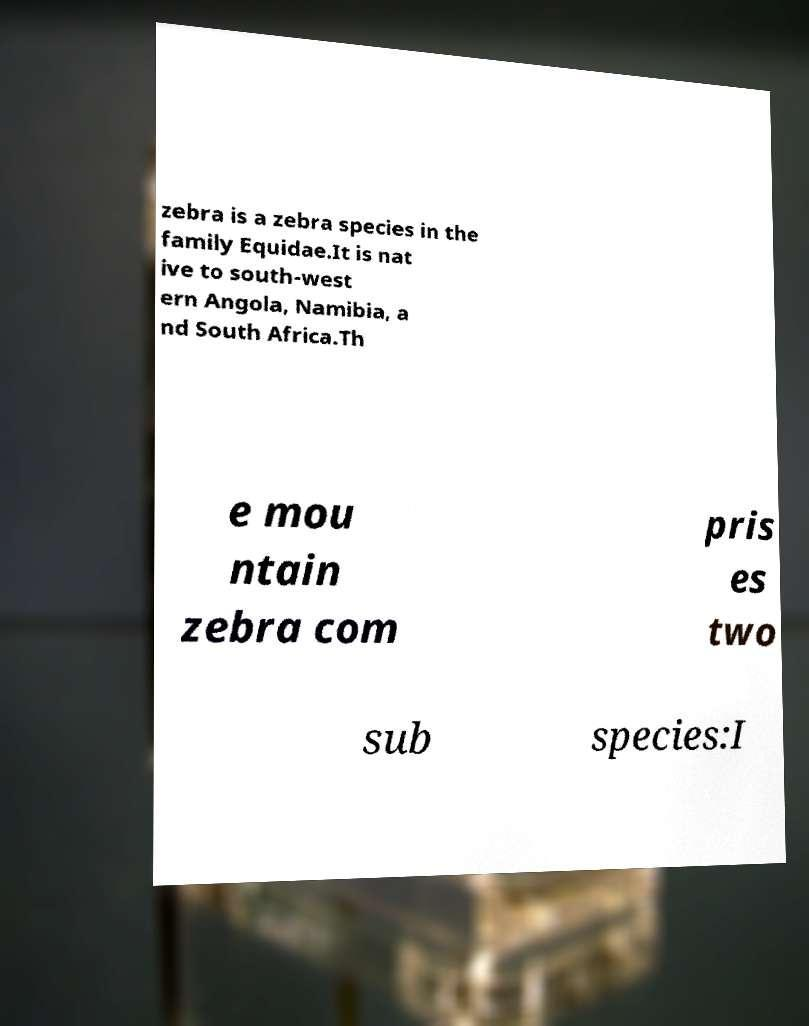There's text embedded in this image that I need extracted. Can you transcribe it verbatim? zebra is a zebra species in the family Equidae.It is nat ive to south-west ern Angola, Namibia, a nd South Africa.Th e mou ntain zebra com pris es two sub species:I 